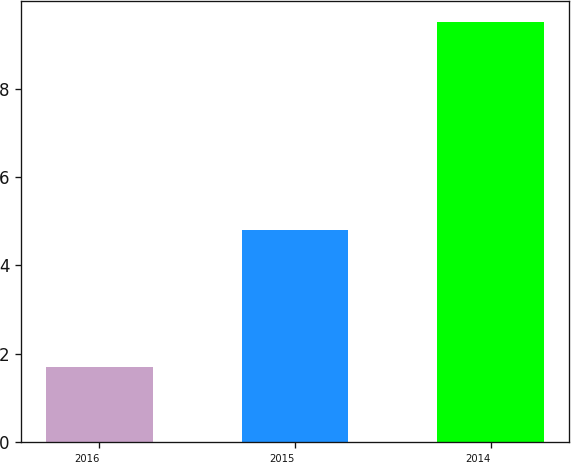Convert chart. <chart><loc_0><loc_0><loc_500><loc_500><bar_chart><fcel>2016<fcel>2015<fcel>2014<nl><fcel>1.7<fcel>4.8<fcel>9.5<nl></chart> 